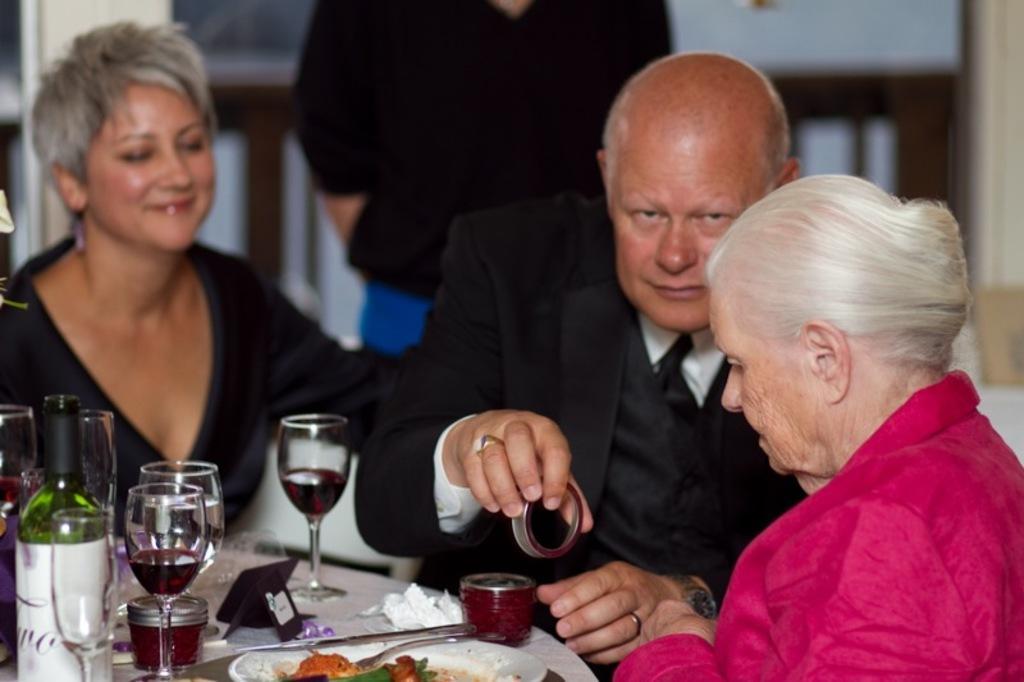Can you describe this image briefly? In this image there are three persons sitting, there are glasses on the table, there is the drink in the glass, there is bottle on the table, there is food on the plate, there is a plate on the table, there are objects on the table, there is a person holding an object, there is a person standing and is truncated. 